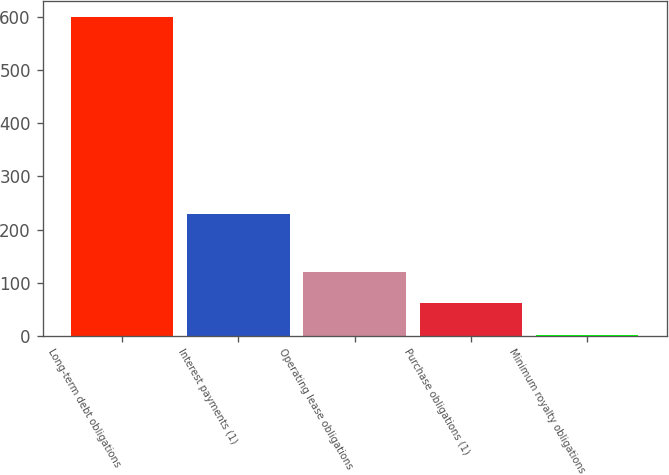Convert chart. <chart><loc_0><loc_0><loc_500><loc_500><bar_chart><fcel>Long-term debt obligations<fcel>Interest payments (1)<fcel>Operating lease obligations<fcel>Purchase obligations (1)<fcel>Minimum royalty obligations<nl><fcel>600<fcel>229<fcel>120.8<fcel>60.9<fcel>1<nl></chart> 